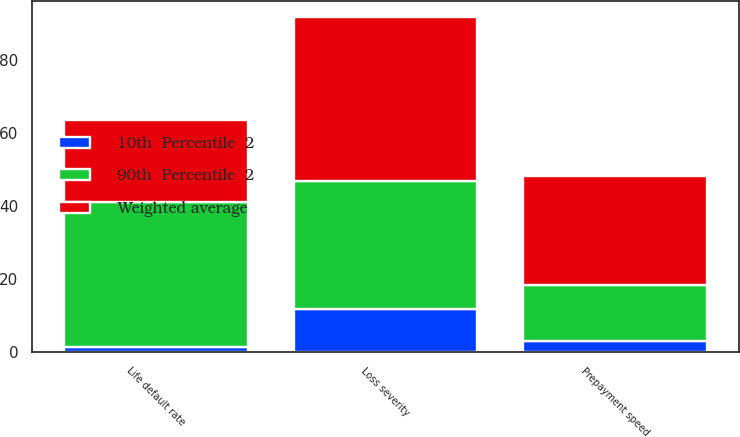Convert chart. <chart><loc_0><loc_0><loc_500><loc_500><stacked_bar_chart><ecel><fcel>Prepayment speed<fcel>Loss severity<fcel>Life default rate<nl><fcel>90th  Percentile  2<fcel>15.3<fcel>35.2<fcel>39.6<nl><fcel>10th  Percentile  2<fcel>3.1<fcel>11.8<fcel>1.5<nl><fcel>Weighted average<fcel>29.9<fcel>44.7<fcel>22.6<nl></chart> 